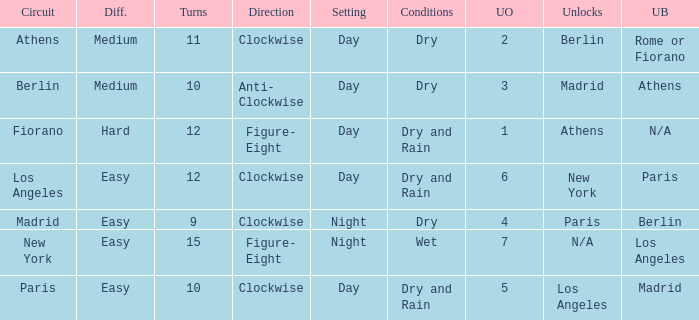What is the difficulty of the athens circuit? Medium. 